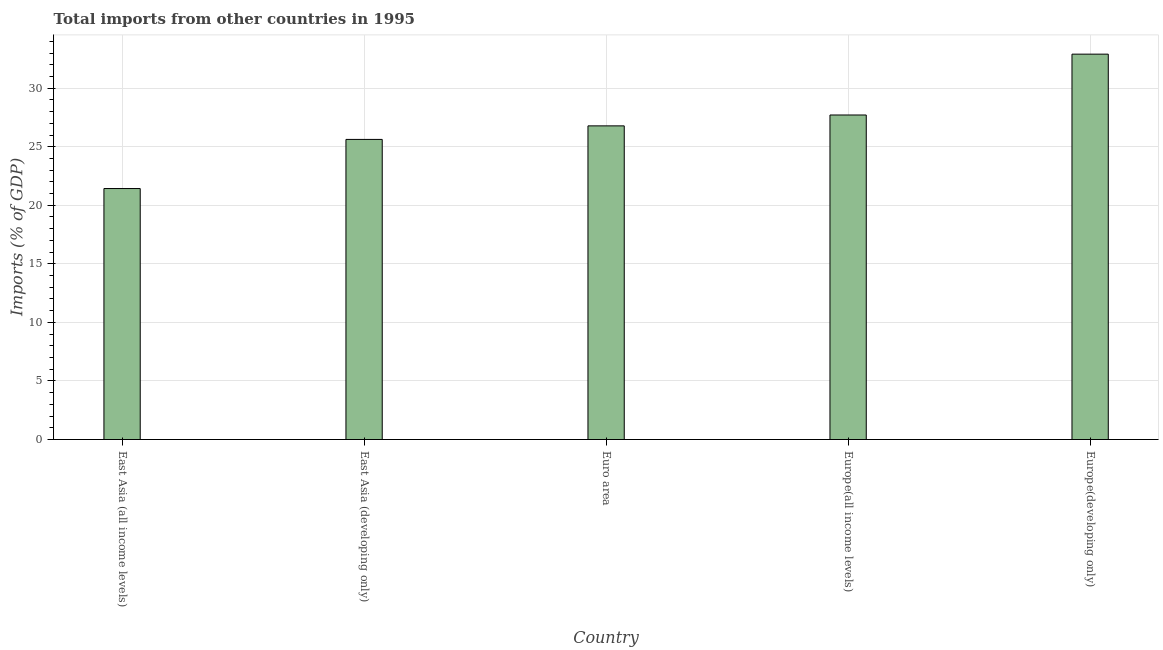What is the title of the graph?
Provide a succinct answer. Total imports from other countries in 1995. What is the label or title of the Y-axis?
Offer a terse response. Imports (% of GDP). What is the total imports in Europe(developing only)?
Provide a short and direct response. 32.9. Across all countries, what is the maximum total imports?
Offer a very short reply. 32.9. Across all countries, what is the minimum total imports?
Offer a terse response. 21.43. In which country was the total imports maximum?
Your response must be concise. Europe(developing only). In which country was the total imports minimum?
Your response must be concise. East Asia (all income levels). What is the sum of the total imports?
Offer a terse response. 134.44. What is the difference between the total imports in Euro area and Europe(all income levels)?
Make the answer very short. -0.93. What is the average total imports per country?
Provide a succinct answer. 26.89. What is the median total imports?
Make the answer very short. 26.78. What is the ratio of the total imports in East Asia (developing only) to that in Europe(developing only)?
Your response must be concise. 0.78. What is the difference between the highest and the second highest total imports?
Provide a short and direct response. 5.2. What is the difference between the highest and the lowest total imports?
Keep it short and to the point. 11.47. In how many countries, is the total imports greater than the average total imports taken over all countries?
Your response must be concise. 2. Are all the bars in the graph horizontal?
Offer a terse response. No. What is the Imports (% of GDP) of East Asia (all income levels)?
Make the answer very short. 21.43. What is the Imports (% of GDP) in East Asia (developing only)?
Offer a terse response. 25.62. What is the Imports (% of GDP) of Euro area?
Keep it short and to the point. 26.78. What is the Imports (% of GDP) in Europe(all income levels)?
Offer a terse response. 27.71. What is the Imports (% of GDP) of Europe(developing only)?
Offer a very short reply. 32.9. What is the difference between the Imports (% of GDP) in East Asia (all income levels) and East Asia (developing only)?
Offer a very short reply. -4.19. What is the difference between the Imports (% of GDP) in East Asia (all income levels) and Euro area?
Offer a very short reply. -5.35. What is the difference between the Imports (% of GDP) in East Asia (all income levels) and Europe(all income levels)?
Your answer should be compact. -6.28. What is the difference between the Imports (% of GDP) in East Asia (all income levels) and Europe(developing only)?
Offer a terse response. -11.47. What is the difference between the Imports (% of GDP) in East Asia (developing only) and Euro area?
Provide a succinct answer. -1.16. What is the difference between the Imports (% of GDP) in East Asia (developing only) and Europe(all income levels)?
Provide a succinct answer. -2.09. What is the difference between the Imports (% of GDP) in East Asia (developing only) and Europe(developing only)?
Give a very brief answer. -7.28. What is the difference between the Imports (% of GDP) in Euro area and Europe(all income levels)?
Provide a succinct answer. -0.93. What is the difference between the Imports (% of GDP) in Euro area and Europe(developing only)?
Keep it short and to the point. -6.12. What is the difference between the Imports (% of GDP) in Europe(all income levels) and Europe(developing only)?
Offer a terse response. -5.2. What is the ratio of the Imports (% of GDP) in East Asia (all income levels) to that in East Asia (developing only)?
Provide a short and direct response. 0.84. What is the ratio of the Imports (% of GDP) in East Asia (all income levels) to that in Europe(all income levels)?
Provide a succinct answer. 0.77. What is the ratio of the Imports (% of GDP) in East Asia (all income levels) to that in Europe(developing only)?
Your response must be concise. 0.65. What is the ratio of the Imports (% of GDP) in East Asia (developing only) to that in Europe(all income levels)?
Your response must be concise. 0.93. What is the ratio of the Imports (% of GDP) in East Asia (developing only) to that in Europe(developing only)?
Your response must be concise. 0.78. What is the ratio of the Imports (% of GDP) in Euro area to that in Europe(all income levels)?
Your answer should be very brief. 0.97. What is the ratio of the Imports (% of GDP) in Euro area to that in Europe(developing only)?
Give a very brief answer. 0.81. What is the ratio of the Imports (% of GDP) in Europe(all income levels) to that in Europe(developing only)?
Offer a terse response. 0.84. 